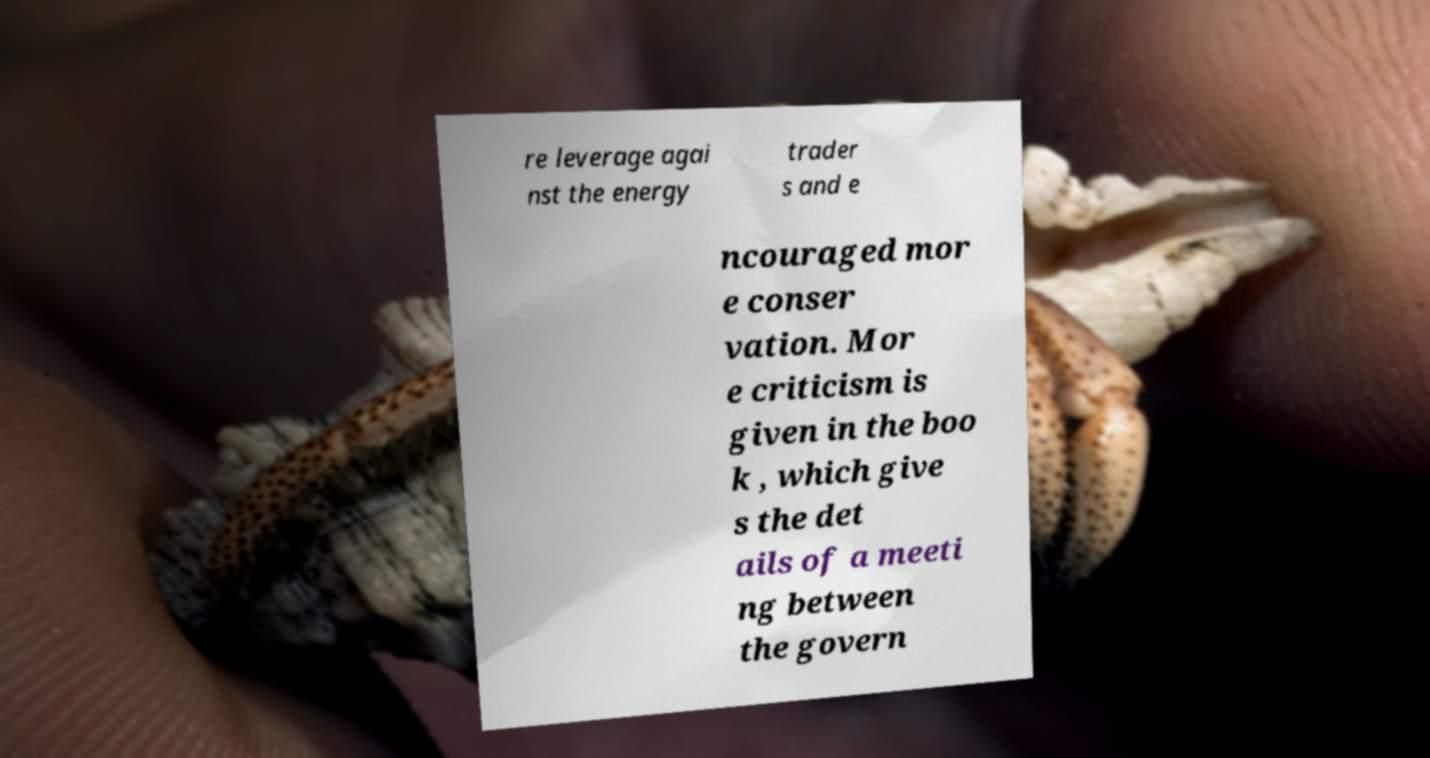Please read and relay the text visible in this image. What does it say? re leverage agai nst the energy trader s and e ncouraged mor e conser vation. Mor e criticism is given in the boo k , which give s the det ails of a meeti ng between the govern 